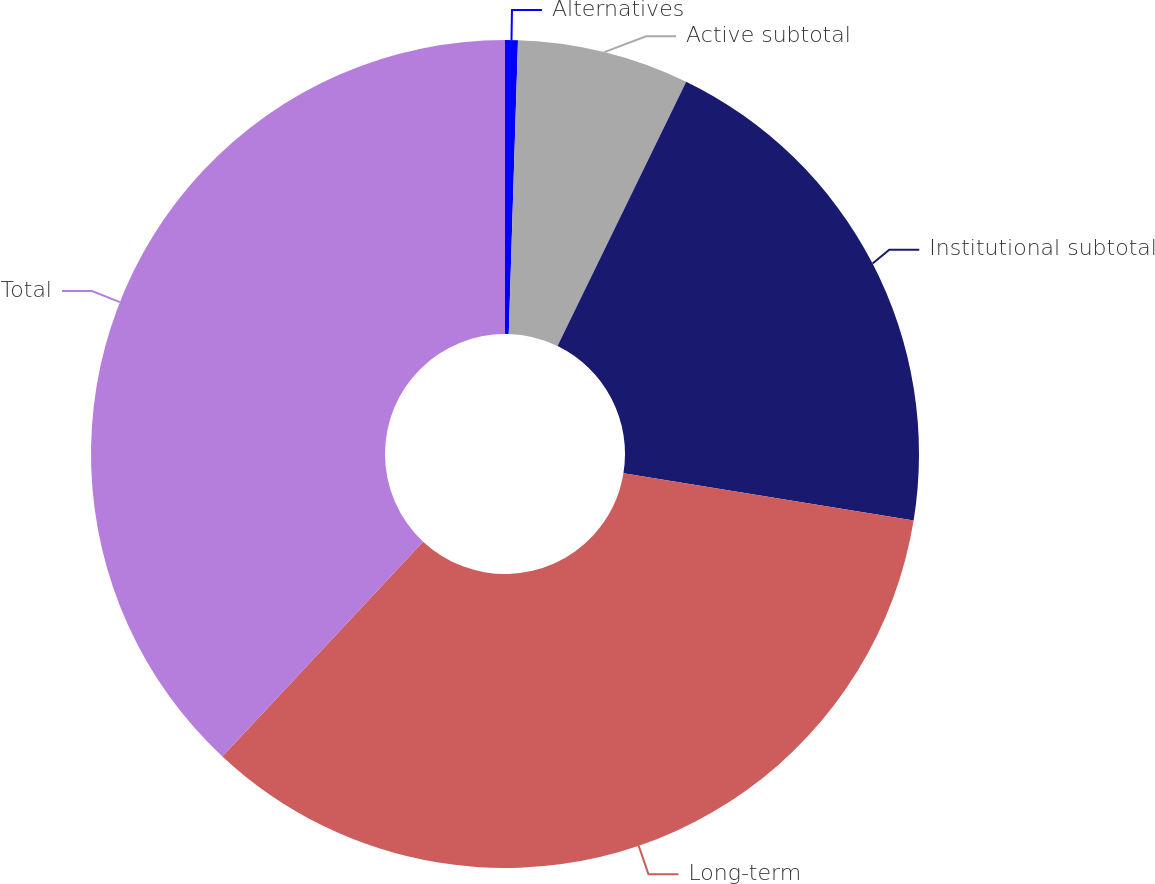<chart> <loc_0><loc_0><loc_500><loc_500><pie_chart><fcel>Alternatives<fcel>Active subtotal<fcel>Institutional subtotal<fcel>Long-term<fcel>Total<nl><fcel>0.5%<fcel>6.71%<fcel>20.36%<fcel>34.39%<fcel>38.04%<nl></chart> 